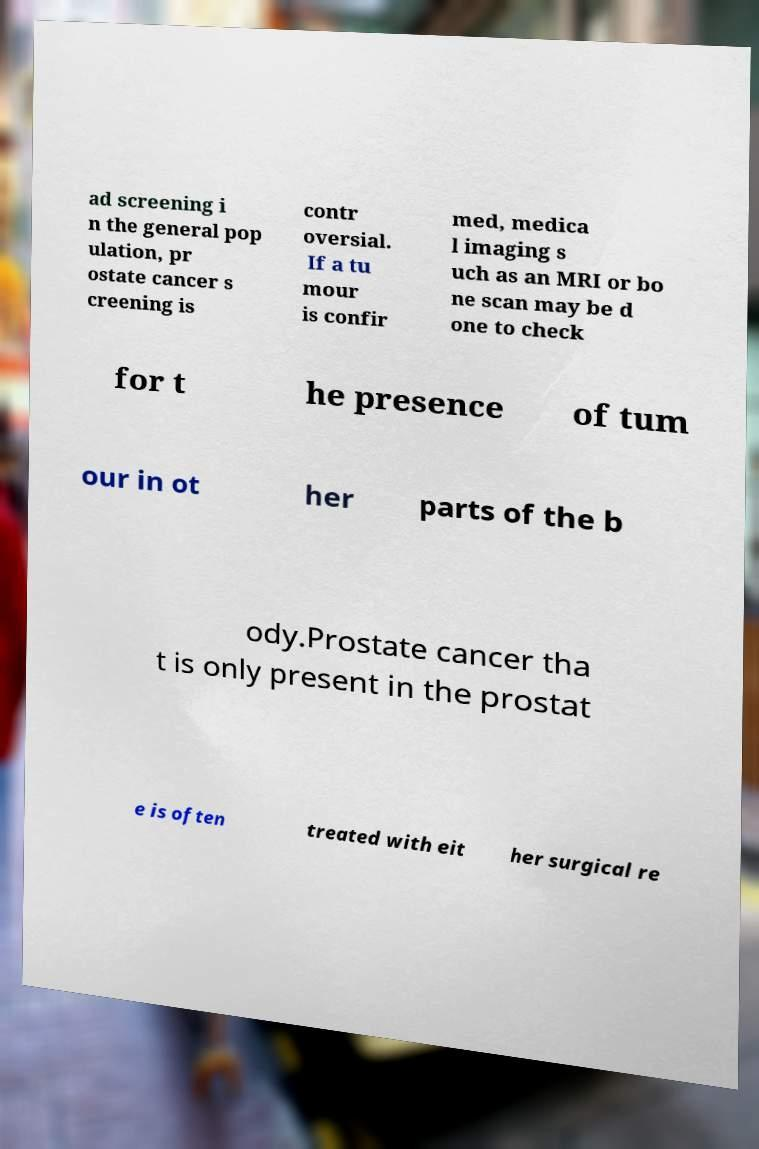Please read and relay the text visible in this image. What does it say? ad screening i n the general pop ulation, pr ostate cancer s creening is contr oversial. If a tu mour is confir med, medica l imaging s uch as an MRI or bo ne scan may be d one to check for t he presence of tum our in ot her parts of the b ody.Prostate cancer tha t is only present in the prostat e is often treated with eit her surgical re 